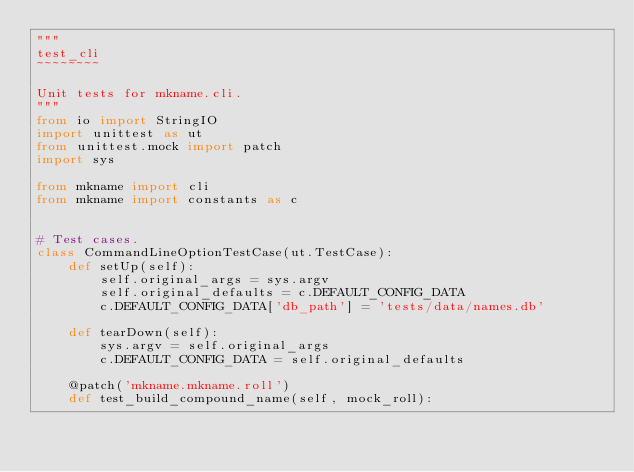<code> <loc_0><loc_0><loc_500><loc_500><_Python_>"""
test_cli
~~~~~~~~

Unit tests for mkname.cli.
"""
from io import StringIO
import unittest as ut
from unittest.mock import patch
import sys

from mkname import cli
from mkname import constants as c


# Test cases.
class CommandLineOptionTestCase(ut.TestCase):
    def setUp(self):
        self.original_args = sys.argv
        self.original_defaults = c.DEFAULT_CONFIG_DATA
        c.DEFAULT_CONFIG_DATA['db_path'] = 'tests/data/names.db'

    def tearDown(self):
        sys.argv = self.original_args
        c.DEFAULT_CONFIG_DATA = self.original_defaults

    @patch('mkname.mkname.roll')
    def test_build_compound_name(self, mock_roll):</code> 